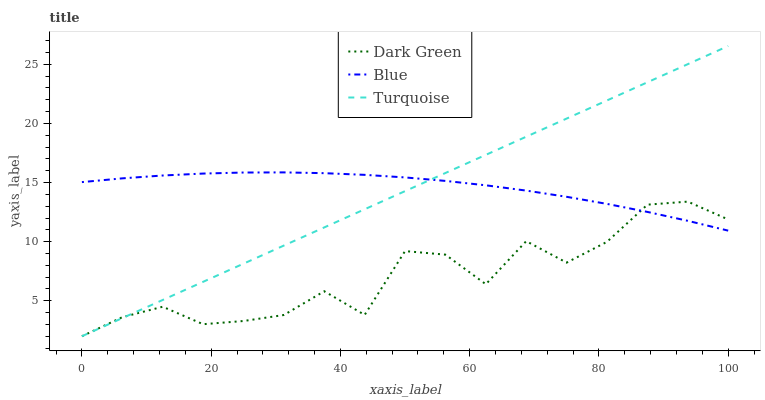Does Dark Green have the minimum area under the curve?
Answer yes or no. Yes. Does Blue have the maximum area under the curve?
Answer yes or no. Yes. Does Turquoise have the minimum area under the curve?
Answer yes or no. No. Does Turquoise have the maximum area under the curve?
Answer yes or no. No. Is Turquoise the smoothest?
Answer yes or no. Yes. Is Dark Green the roughest?
Answer yes or no. Yes. Is Dark Green the smoothest?
Answer yes or no. No. Is Turquoise the roughest?
Answer yes or no. No. Does Turquoise have the lowest value?
Answer yes or no. Yes. Does Turquoise have the highest value?
Answer yes or no. Yes. Does Dark Green have the highest value?
Answer yes or no. No. Does Turquoise intersect Dark Green?
Answer yes or no. Yes. Is Turquoise less than Dark Green?
Answer yes or no. No. Is Turquoise greater than Dark Green?
Answer yes or no. No. 